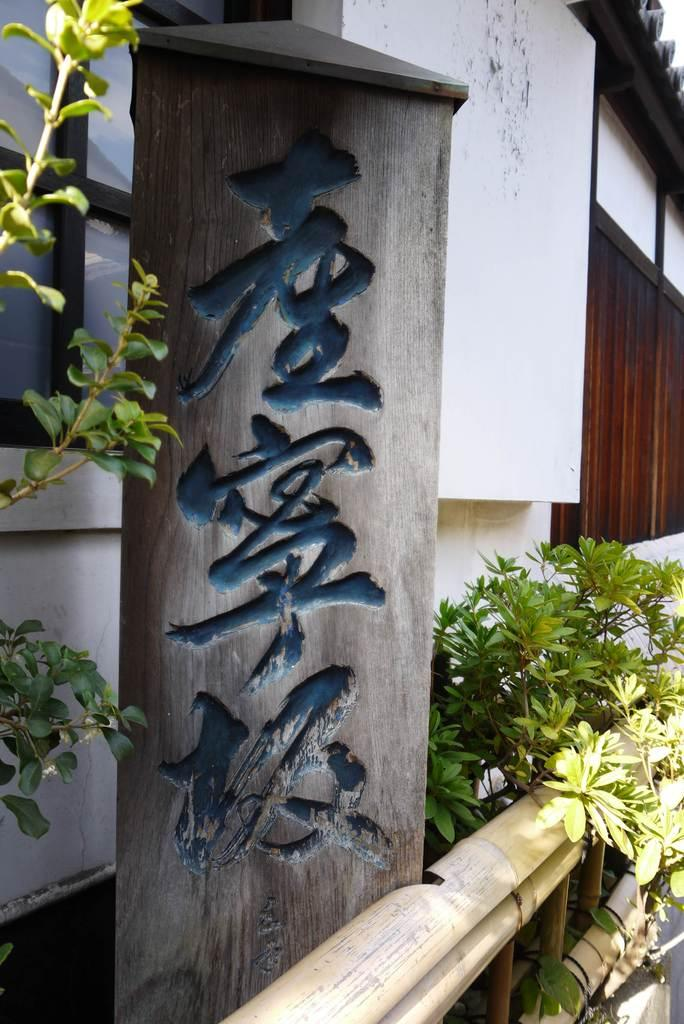What type of structure is visible in the image? There is a house in the image. What other elements can be seen in the image besides the house? There are plants and a board with words in the image. Are there any dinosaurs visible in the image? No, there are no dinosaurs present in the image. What type of trade is being conducted in the image? There is no trade being conducted in the image; it only features a house, plants, and a board with words. 